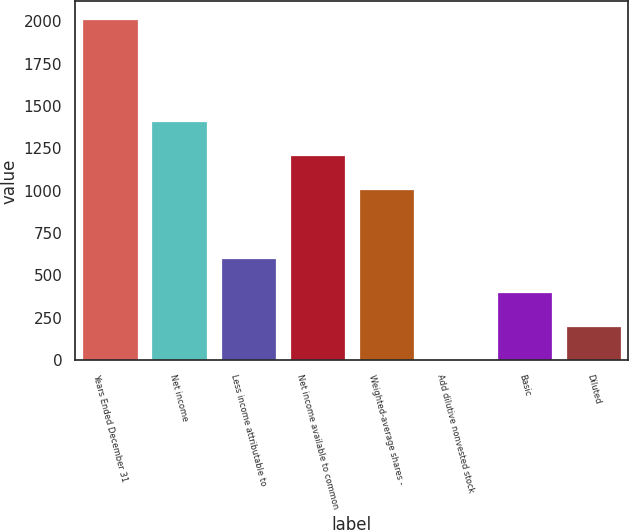Convert chart. <chart><loc_0><loc_0><loc_500><loc_500><bar_chart><fcel>Years Ended December 31<fcel>Net income<fcel>Less income attributable to<fcel>Net income available to common<fcel>Weighted-average shares -<fcel>Add dilutive nonvested stock<fcel>Basic<fcel>Diluted<nl><fcel>2016<fcel>1411.5<fcel>605.5<fcel>1210<fcel>1008.5<fcel>1<fcel>404<fcel>202.5<nl></chart> 